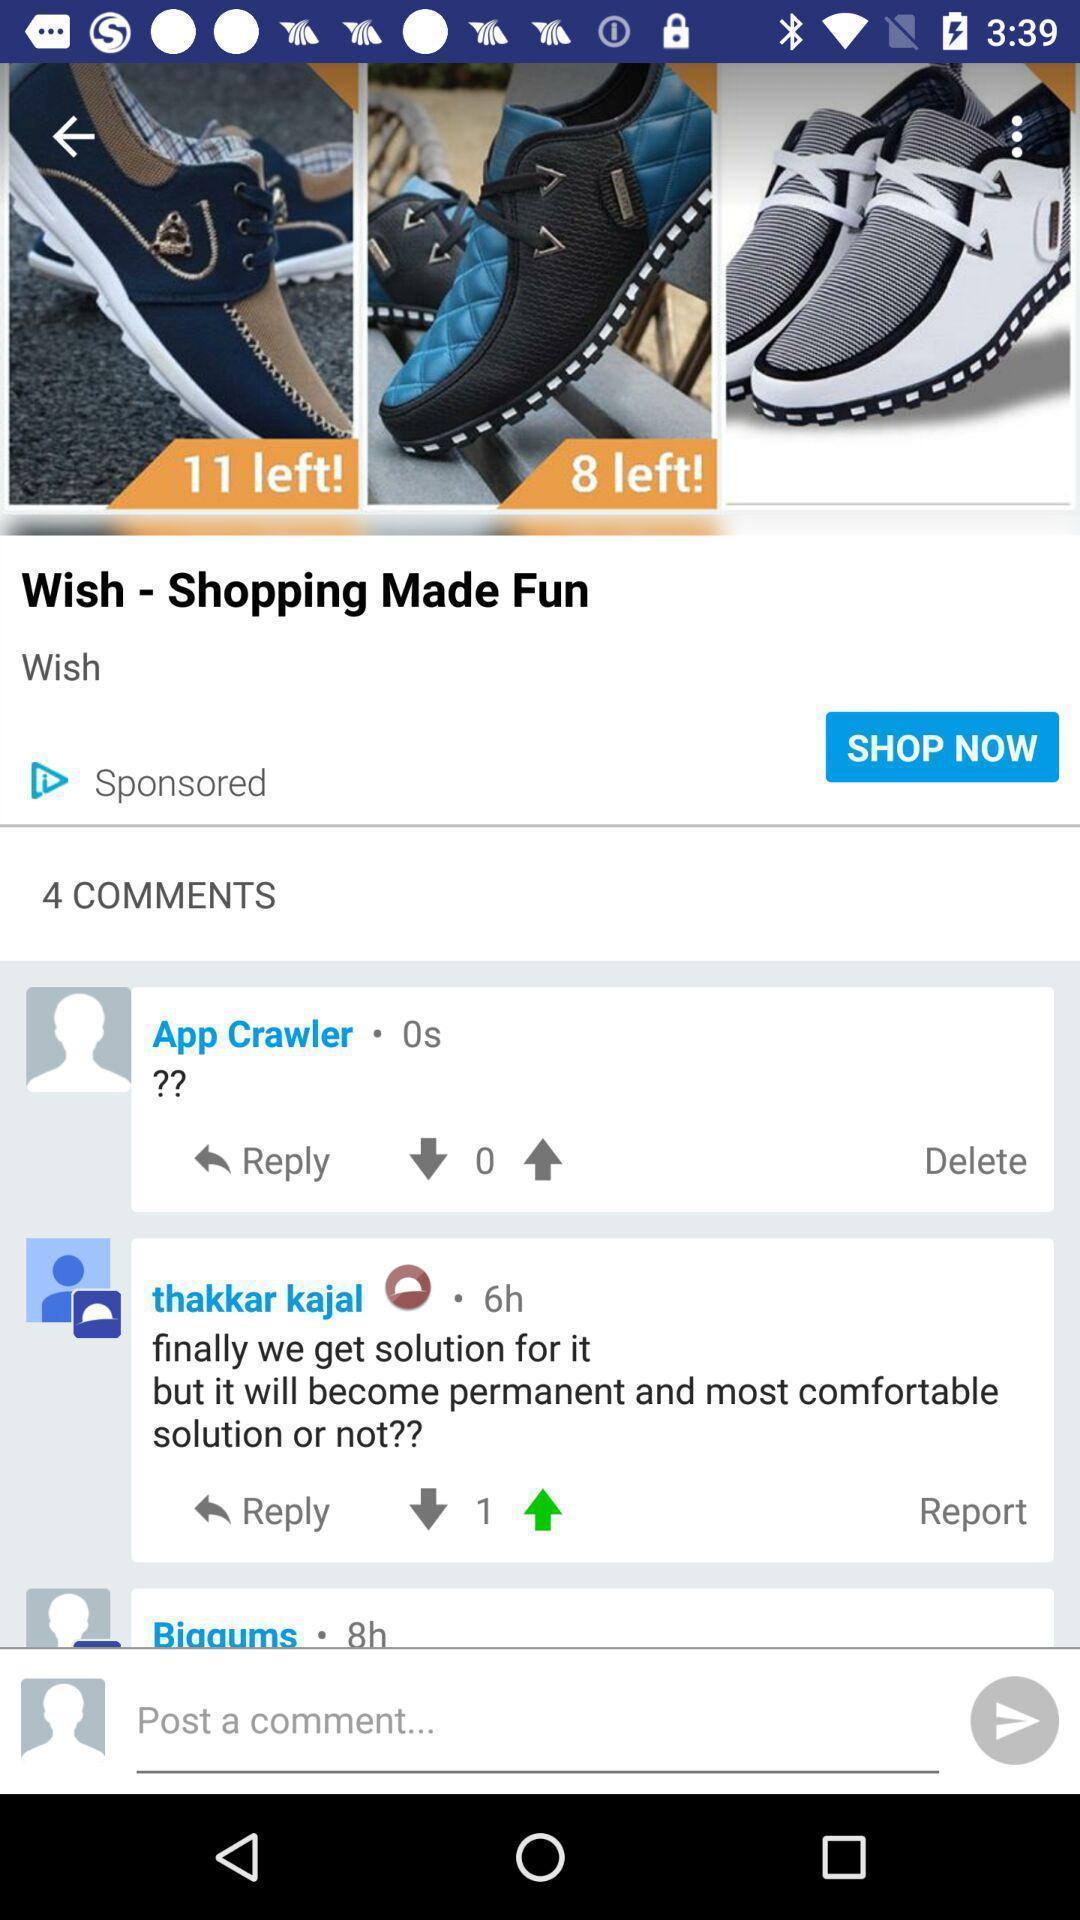Tell me about the visual elements in this screen capture. Screen displaying the page of a shopping app. 